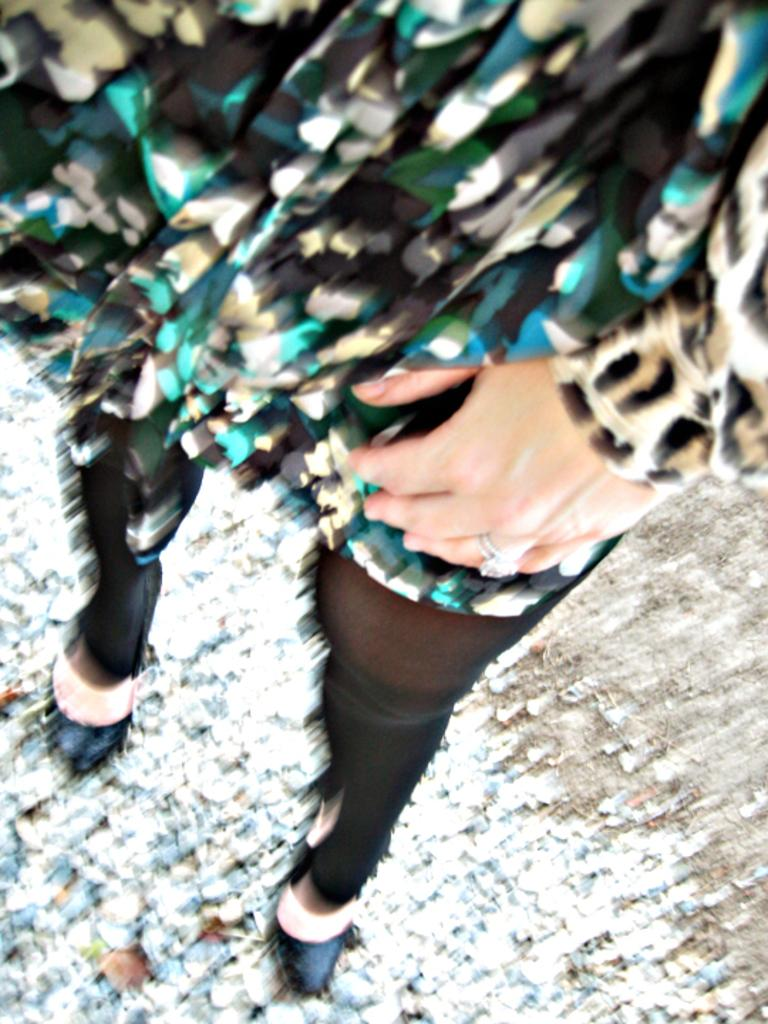What is the main subject of the image? There is a person in the image. What can be seen at the bottom of the image? There are stones at the bottom of the image. What type of bone can be seen in the image? There is no bone present in the image. Is there a rainstorm happening in the image? There is no indication of a rainstorm in the image. 